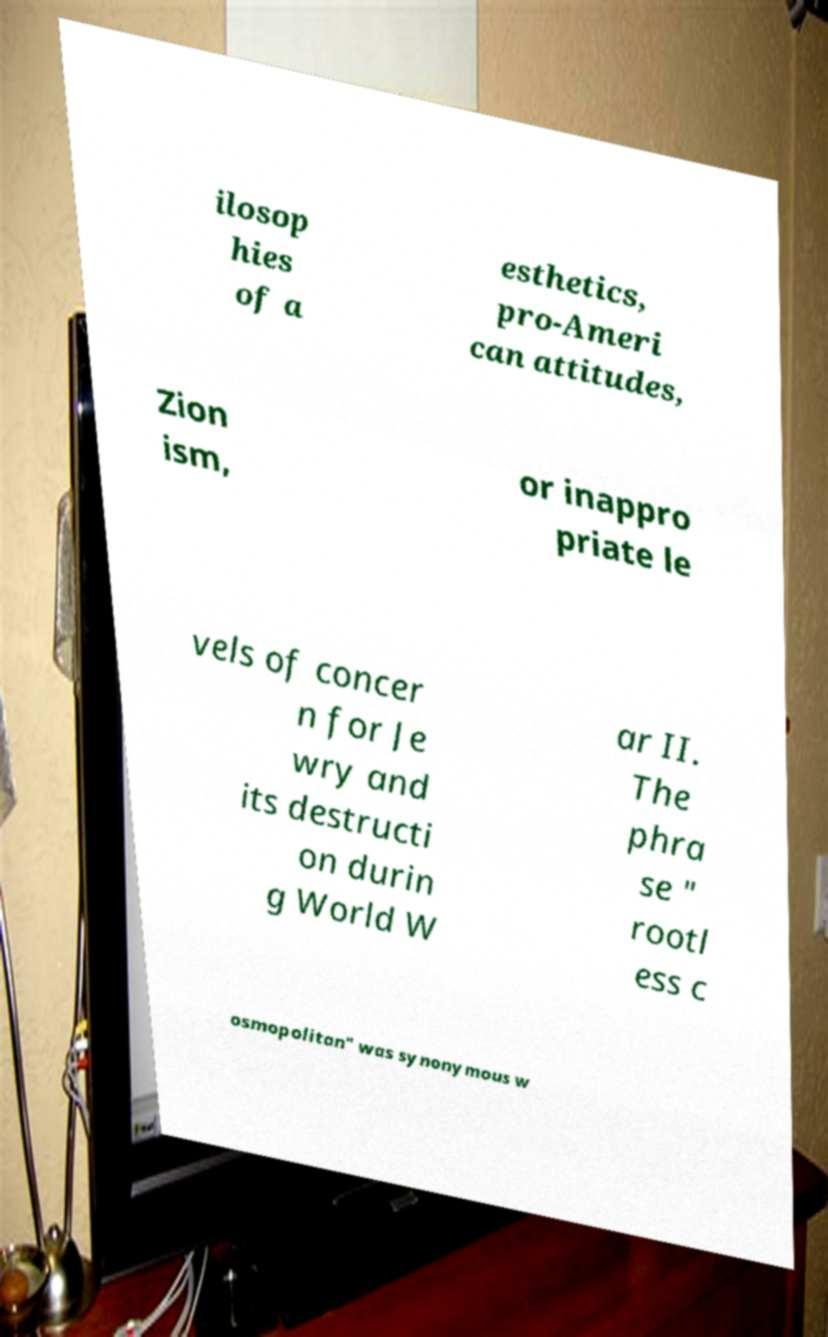Please read and relay the text visible in this image. What does it say? ilosop hies of a esthetics, pro-Ameri can attitudes, Zion ism, or inappro priate le vels of concer n for Je wry and its destructi on durin g World W ar II. The phra se " rootl ess c osmopolitan" was synonymous w 